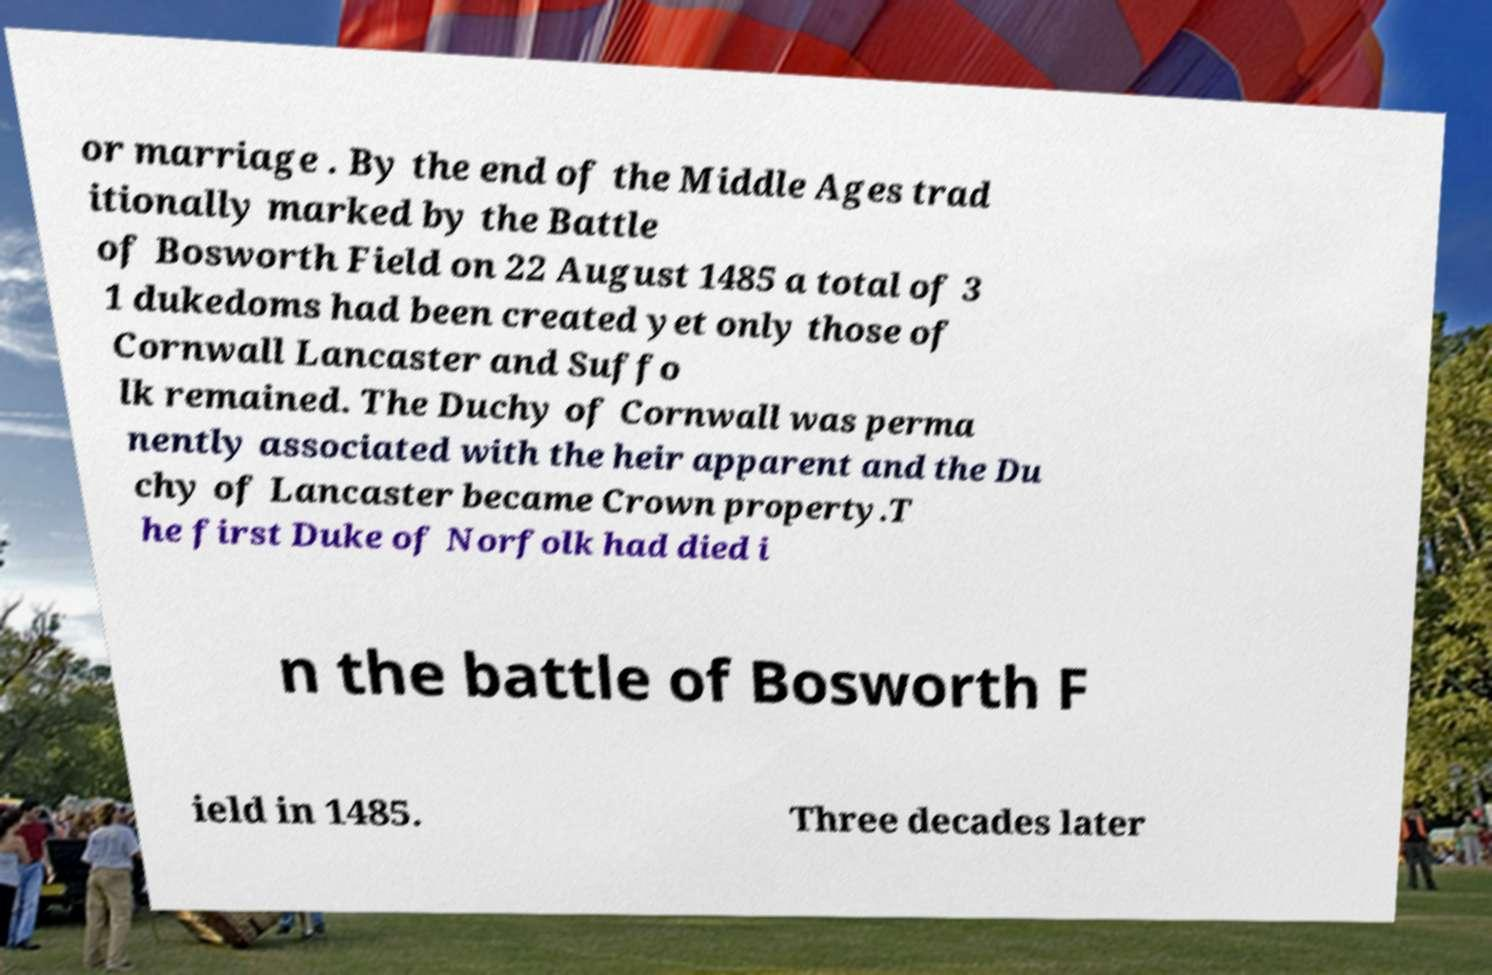I need the written content from this picture converted into text. Can you do that? or marriage . By the end of the Middle Ages trad itionally marked by the Battle of Bosworth Field on 22 August 1485 a total of 3 1 dukedoms had been created yet only those of Cornwall Lancaster and Suffo lk remained. The Duchy of Cornwall was perma nently associated with the heir apparent and the Du chy of Lancaster became Crown property.T he first Duke of Norfolk had died i n the battle of Bosworth F ield in 1485. Three decades later 